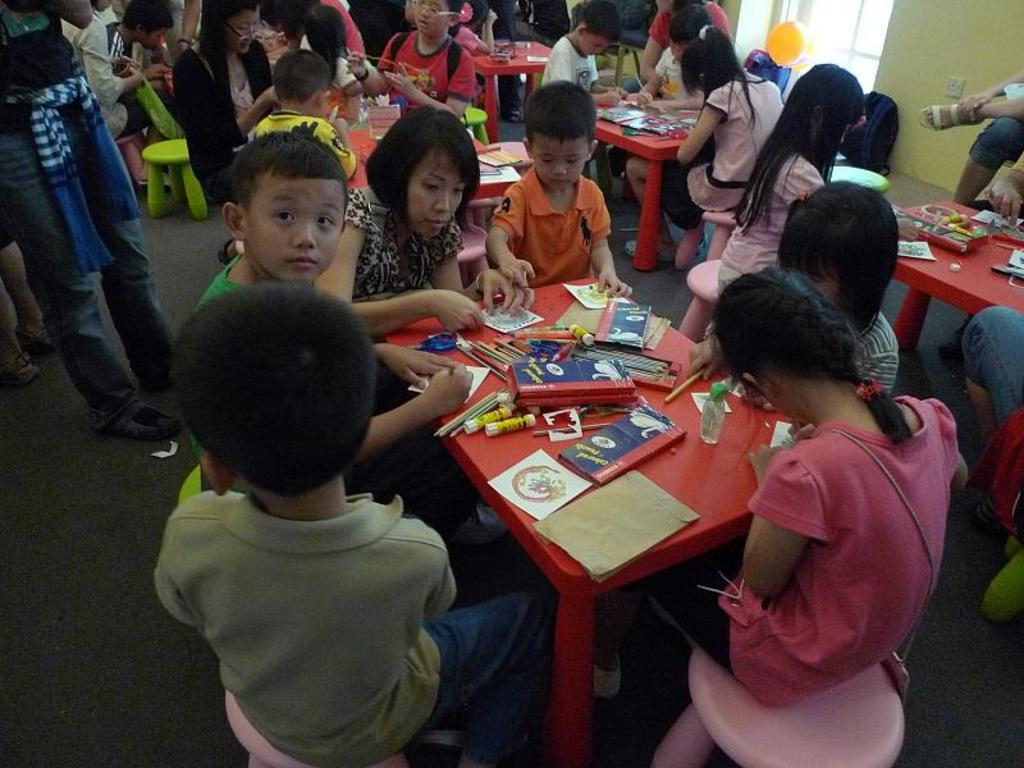What is happening in the image? There is a group of people in the image, and they are sitting around a table. What are the people doing while sitting around the table? The people are playing with drawing instruments. What type of coal is being used by the people in the image? There is no coal present in the image; the people are playing with drawing instruments. How many beds are visible in the image? There are no beds visible in the image; it features a group of people sitting around a table. 